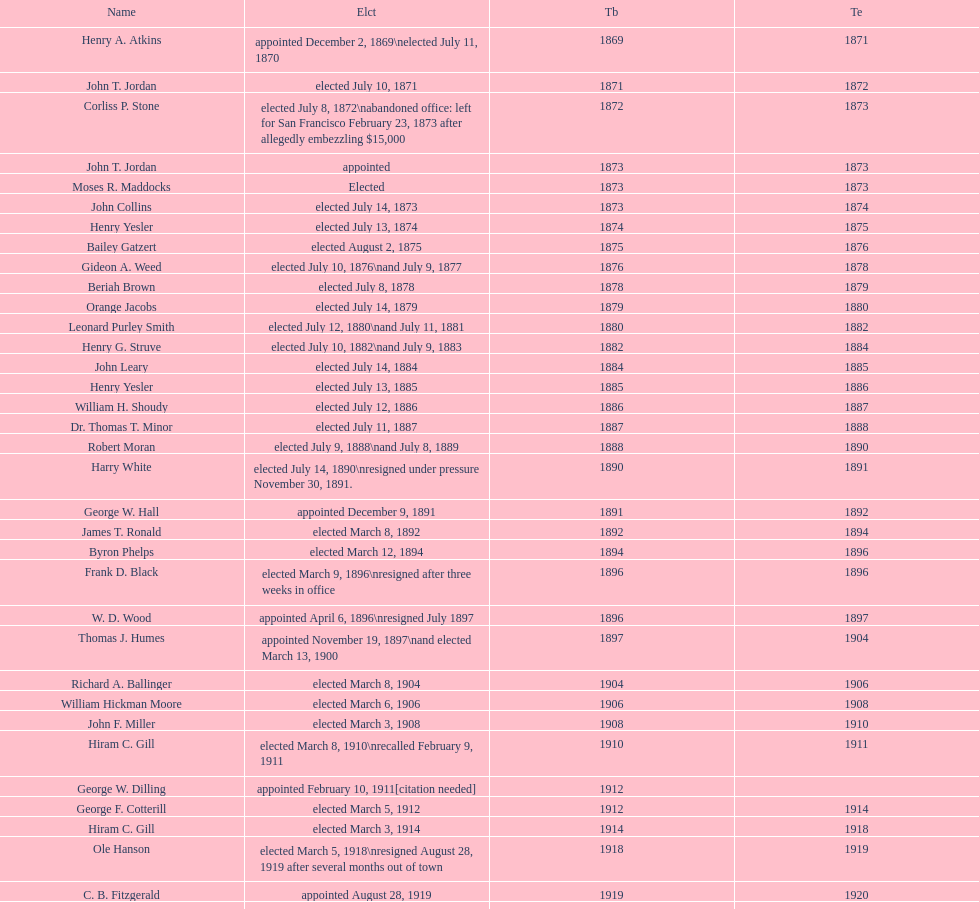How many days did robert moran serve? 365. 